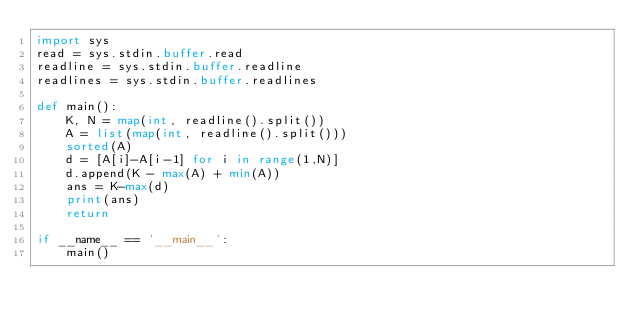Convert code to text. <code><loc_0><loc_0><loc_500><loc_500><_Python_>import sys
read = sys.stdin.buffer.read
readline = sys.stdin.buffer.readline
readlines = sys.stdin.buffer.readlines

def main():
    K, N = map(int, readline().split())
    A = list(map(int, readline().split()))
    sorted(A)
    d = [A[i]-A[i-1] for i in range(1,N)]
    d.append(K - max(A) + min(A))
    ans = K-max(d)
    print(ans)
    return

if __name__ == '__main__':
    main()
</code> 